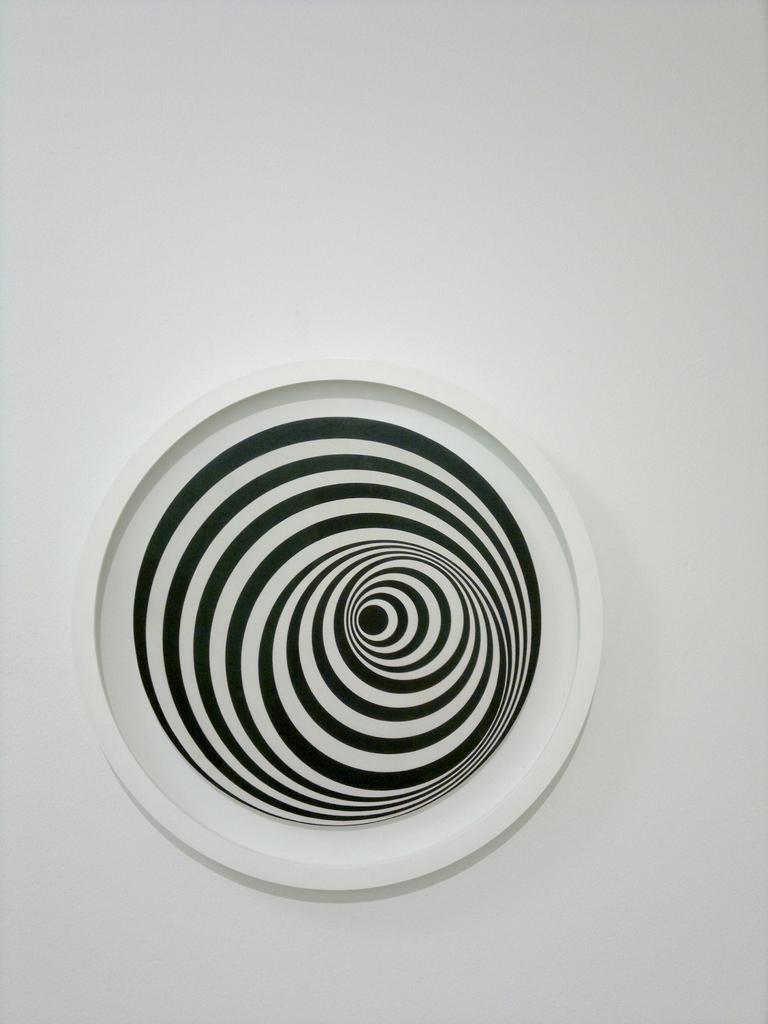Could you give a brief overview of what you see in this image? In this image I can see the white and black color plate. It is on the white color surface. 